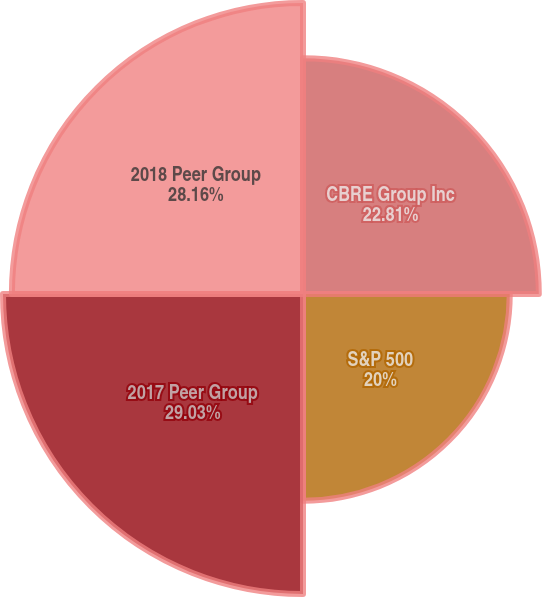Convert chart to OTSL. <chart><loc_0><loc_0><loc_500><loc_500><pie_chart><fcel>CBRE Group Inc<fcel>S&P 500<fcel>2017 Peer Group<fcel>2018 Peer Group<nl><fcel>22.81%<fcel>20.0%<fcel>29.02%<fcel>28.16%<nl></chart> 